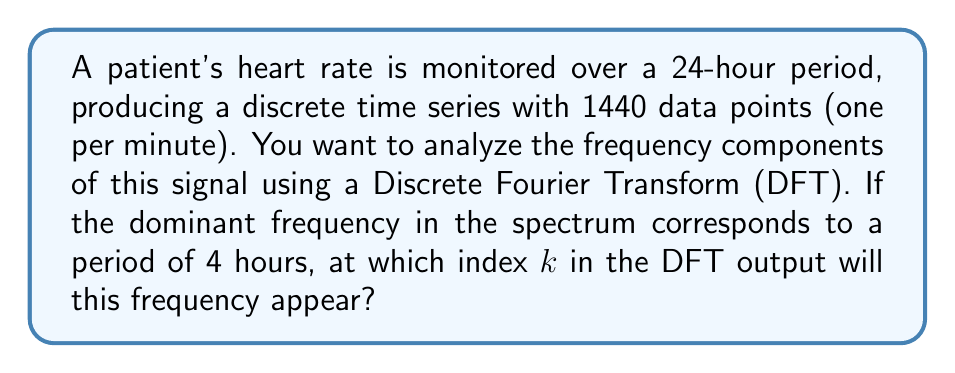What is the answer to this math problem? Let's approach this step-by-step:

1) The Discrete Fourier Transform (DFT) of a signal with N points gives us N frequency components, indexed from 0 to N-1.

2) In this case, N = 1440 (24 hours * 60 minutes/hour).

3) The frequency resolution of the DFT is given by:

   $$\Delta f = \frac{f_s}{N}$$

   where $f_s$ is the sampling frequency.

4) Here, $f_s = \frac{1}{60}$ Hz (1 sample per minute = 1/60 samples per second)

5) So, $$\Delta f = \frac{1/60}{1440} = \frac{1}{86400}$$ Hz

6) The dominant frequency we're looking for has a period of 4 hours. Let's call this frequency $f_d$:

   $$f_d = \frac{1}{4 \text{ hours}} = \frac{1}{4 * 3600 \text{ seconds}} = \frac{1}{14400}$$ Hz

7) The index k where this frequency appears is given by:

   $$k = \frac{f_d}{\Delta f} = \frac{1/14400}{1/86400} = 6$$

Therefore, the dominant frequency will appear at index k = 6 in the DFT output.
Answer: 6 